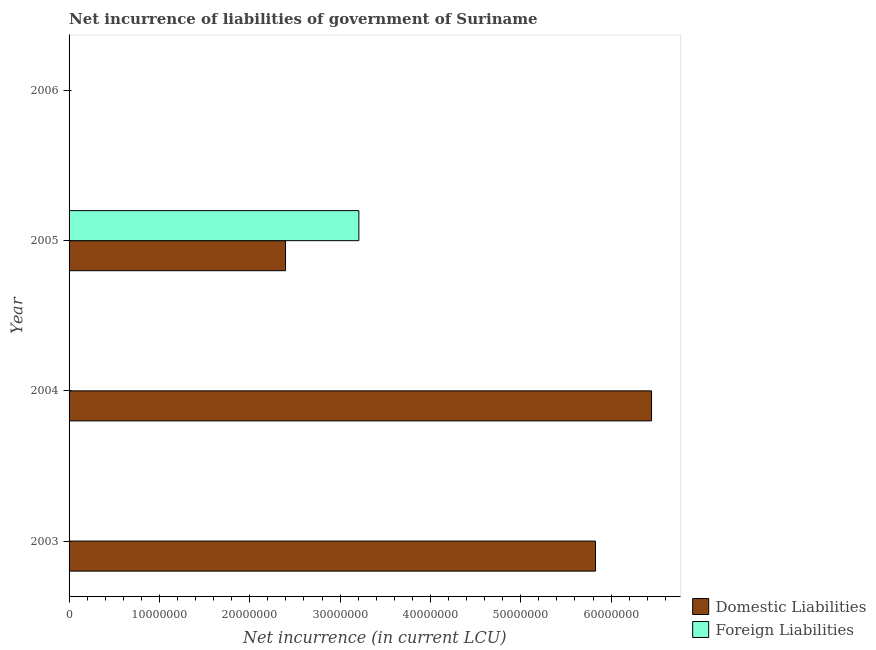Are the number of bars per tick equal to the number of legend labels?
Ensure brevity in your answer.  No. Are the number of bars on each tick of the Y-axis equal?
Your response must be concise. No. How many bars are there on the 4th tick from the bottom?
Make the answer very short. 0. What is the label of the 3rd group of bars from the top?
Your response must be concise. 2004. In how many cases, is the number of bars for a given year not equal to the number of legend labels?
Give a very brief answer. 3. What is the net incurrence of foreign liabilities in 2005?
Your answer should be compact. 3.21e+07. Across all years, what is the maximum net incurrence of foreign liabilities?
Give a very brief answer. 3.21e+07. Across all years, what is the minimum net incurrence of domestic liabilities?
Provide a succinct answer. 0. What is the total net incurrence of domestic liabilities in the graph?
Give a very brief answer. 1.47e+08. What is the difference between the net incurrence of domestic liabilities in 2003 and that in 2004?
Your answer should be compact. -6.21e+06. What is the difference between the net incurrence of foreign liabilities in 2005 and the net incurrence of domestic liabilities in 2003?
Your response must be concise. -2.62e+07. What is the average net incurrence of foreign liabilities per year?
Provide a short and direct response. 8.02e+06. In the year 2005, what is the difference between the net incurrence of domestic liabilities and net incurrence of foreign liabilities?
Make the answer very short. -8.12e+06. In how many years, is the net incurrence of foreign liabilities greater than 24000000 LCU?
Your answer should be compact. 1. What is the ratio of the net incurrence of domestic liabilities in 2004 to that in 2005?
Offer a terse response. 2.69. What is the difference between the highest and the second highest net incurrence of domestic liabilities?
Make the answer very short. 6.21e+06. What is the difference between the highest and the lowest net incurrence of foreign liabilities?
Your answer should be very brief. 3.21e+07. In how many years, is the net incurrence of domestic liabilities greater than the average net incurrence of domestic liabilities taken over all years?
Give a very brief answer. 2. Is the sum of the net incurrence of domestic liabilities in 2003 and 2005 greater than the maximum net incurrence of foreign liabilities across all years?
Keep it short and to the point. Yes. How many years are there in the graph?
Make the answer very short. 4. What is the difference between two consecutive major ticks on the X-axis?
Provide a succinct answer. 1.00e+07. Are the values on the major ticks of X-axis written in scientific E-notation?
Provide a succinct answer. No. How many legend labels are there?
Keep it short and to the point. 2. How are the legend labels stacked?
Make the answer very short. Vertical. What is the title of the graph?
Your answer should be very brief. Net incurrence of liabilities of government of Suriname. Does "Number of arrivals" appear as one of the legend labels in the graph?
Keep it short and to the point. No. What is the label or title of the X-axis?
Your answer should be compact. Net incurrence (in current LCU). What is the Net incurrence (in current LCU) of Domestic Liabilities in 2003?
Your answer should be very brief. 5.83e+07. What is the Net incurrence (in current LCU) of Foreign Liabilities in 2003?
Ensure brevity in your answer.  0. What is the Net incurrence (in current LCU) of Domestic Liabilities in 2004?
Your answer should be compact. 6.45e+07. What is the Net incurrence (in current LCU) of Foreign Liabilities in 2004?
Keep it short and to the point. 0. What is the Net incurrence (in current LCU) in Domestic Liabilities in 2005?
Ensure brevity in your answer.  2.40e+07. What is the Net incurrence (in current LCU) of Foreign Liabilities in 2005?
Your answer should be compact. 3.21e+07. What is the Net incurrence (in current LCU) in Domestic Liabilities in 2006?
Provide a succinct answer. 0. What is the Net incurrence (in current LCU) of Foreign Liabilities in 2006?
Your answer should be compact. 0. Across all years, what is the maximum Net incurrence (in current LCU) in Domestic Liabilities?
Your answer should be compact. 6.45e+07. Across all years, what is the maximum Net incurrence (in current LCU) of Foreign Liabilities?
Your response must be concise. 3.21e+07. Across all years, what is the minimum Net incurrence (in current LCU) of Foreign Liabilities?
Your response must be concise. 0. What is the total Net incurrence (in current LCU) of Domestic Liabilities in the graph?
Offer a very short reply. 1.47e+08. What is the total Net incurrence (in current LCU) in Foreign Liabilities in the graph?
Offer a terse response. 3.21e+07. What is the difference between the Net incurrence (in current LCU) in Domestic Liabilities in 2003 and that in 2004?
Give a very brief answer. -6.21e+06. What is the difference between the Net incurrence (in current LCU) of Domestic Liabilities in 2003 and that in 2005?
Provide a succinct answer. 3.43e+07. What is the difference between the Net incurrence (in current LCU) of Domestic Liabilities in 2004 and that in 2005?
Give a very brief answer. 4.05e+07. What is the difference between the Net incurrence (in current LCU) of Domestic Liabilities in 2003 and the Net incurrence (in current LCU) of Foreign Liabilities in 2005?
Ensure brevity in your answer.  2.62e+07. What is the difference between the Net incurrence (in current LCU) in Domestic Liabilities in 2004 and the Net incurrence (in current LCU) in Foreign Liabilities in 2005?
Your answer should be compact. 3.24e+07. What is the average Net incurrence (in current LCU) in Domestic Liabilities per year?
Offer a very short reply. 3.67e+07. What is the average Net incurrence (in current LCU) of Foreign Liabilities per year?
Your answer should be compact. 8.02e+06. In the year 2005, what is the difference between the Net incurrence (in current LCU) of Domestic Liabilities and Net incurrence (in current LCU) of Foreign Liabilities?
Offer a terse response. -8.12e+06. What is the ratio of the Net incurrence (in current LCU) in Domestic Liabilities in 2003 to that in 2004?
Your answer should be compact. 0.9. What is the ratio of the Net incurrence (in current LCU) in Domestic Liabilities in 2003 to that in 2005?
Offer a terse response. 2.43. What is the ratio of the Net incurrence (in current LCU) of Domestic Liabilities in 2004 to that in 2005?
Your answer should be very brief. 2.69. What is the difference between the highest and the second highest Net incurrence (in current LCU) of Domestic Liabilities?
Your answer should be compact. 6.21e+06. What is the difference between the highest and the lowest Net incurrence (in current LCU) in Domestic Liabilities?
Offer a terse response. 6.45e+07. What is the difference between the highest and the lowest Net incurrence (in current LCU) in Foreign Liabilities?
Your answer should be very brief. 3.21e+07. 